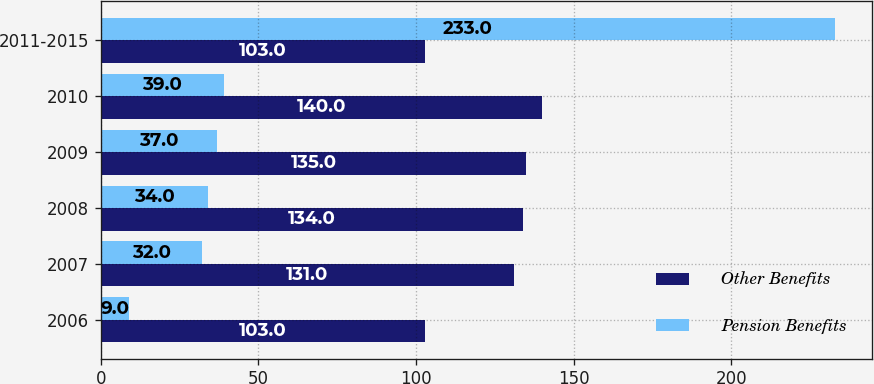<chart> <loc_0><loc_0><loc_500><loc_500><stacked_bar_chart><ecel><fcel>2006<fcel>2007<fcel>2008<fcel>2009<fcel>2010<fcel>2011-2015<nl><fcel>Other Benefits<fcel>103<fcel>131<fcel>134<fcel>135<fcel>140<fcel>103<nl><fcel>Pension Benefits<fcel>9<fcel>32<fcel>34<fcel>37<fcel>39<fcel>233<nl></chart> 